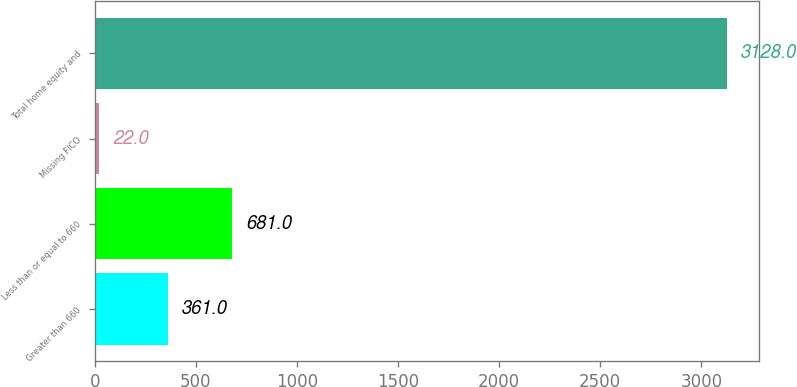Convert chart. <chart><loc_0><loc_0><loc_500><loc_500><bar_chart><fcel>Greater than 660<fcel>Less than or equal to 660<fcel>Missing FICO<fcel>Total home equity and<nl><fcel>361<fcel>681<fcel>22<fcel>3128<nl></chart> 